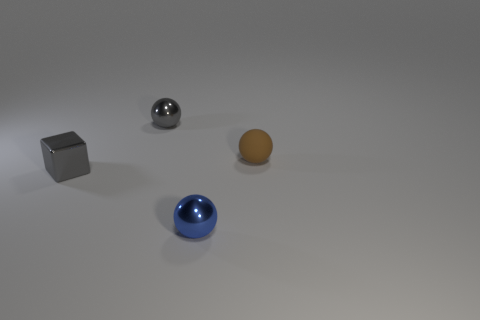Are there any other things that have the same material as the tiny brown thing?
Provide a short and direct response. No. There is a object that is to the left of the brown ball and behind the tiny shiny block; what is its shape?
Your answer should be very brief. Sphere. How many small spheres are the same color as the tiny block?
Make the answer very short. 1. There is a metallic object on the left side of the metallic ball that is behind the small metallic block; is there a small metal cube left of it?
Provide a succinct answer. No. What is the size of the ball that is in front of the gray metallic ball and left of the brown sphere?
Make the answer very short. Small. How many cubes have the same material as the blue sphere?
Offer a terse response. 1. How many cylinders are small gray metallic objects or small blue shiny things?
Give a very brief answer. 0. There is a gray thing on the right side of the gray thing that is in front of the tiny metal ball that is behind the matte thing; what is its size?
Ensure brevity in your answer.  Small. What is the color of the small object that is behind the gray block and on the left side of the small blue metallic sphere?
Ensure brevity in your answer.  Gray. There is a gray ball; is its size the same as the thing that is right of the blue thing?
Your response must be concise. Yes. 